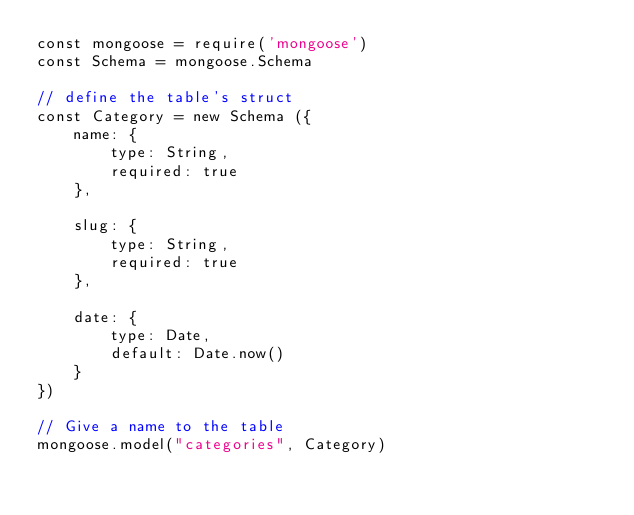<code> <loc_0><loc_0><loc_500><loc_500><_JavaScript_>const mongoose = require('mongoose')
const Schema = mongoose.Schema

// define the table's struct
const Category = new Schema ({
    name: {
        type: String,
        required: true
    },

    slug: {
        type: String,
        required: true
    },

    date: {
        type: Date,
        default: Date.now()
    }
})

// Give a name to the table
mongoose.model("categories", Category)</code> 